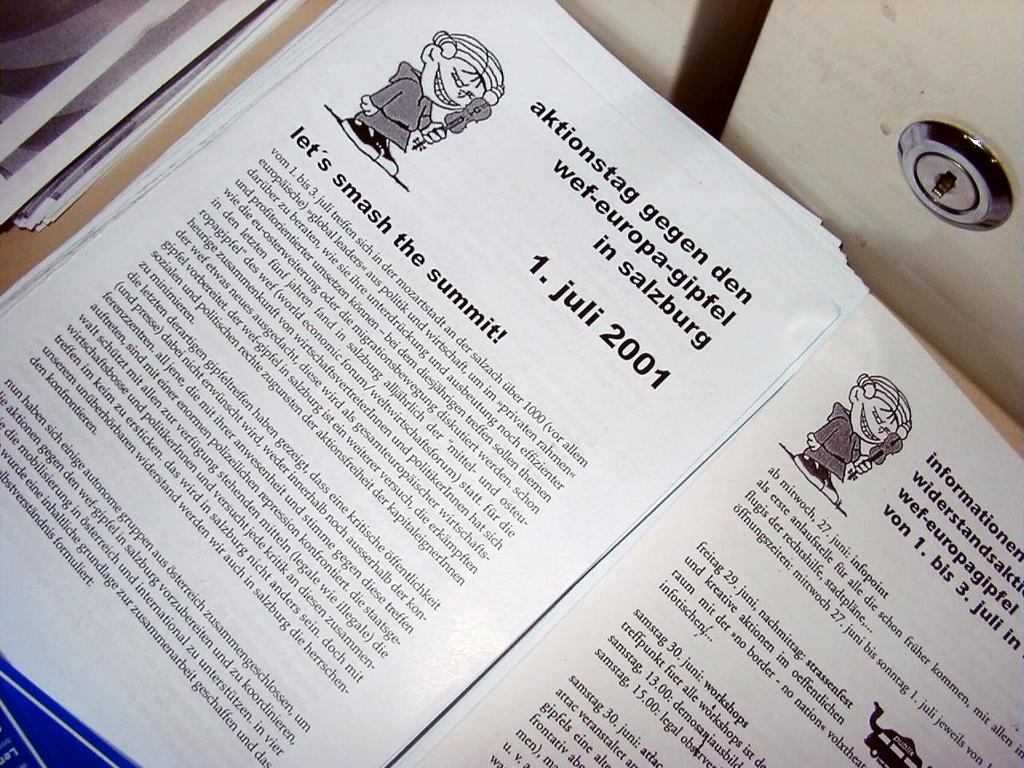<image>
Describe the image concisely. a book with the date of Juli 2001 in it 